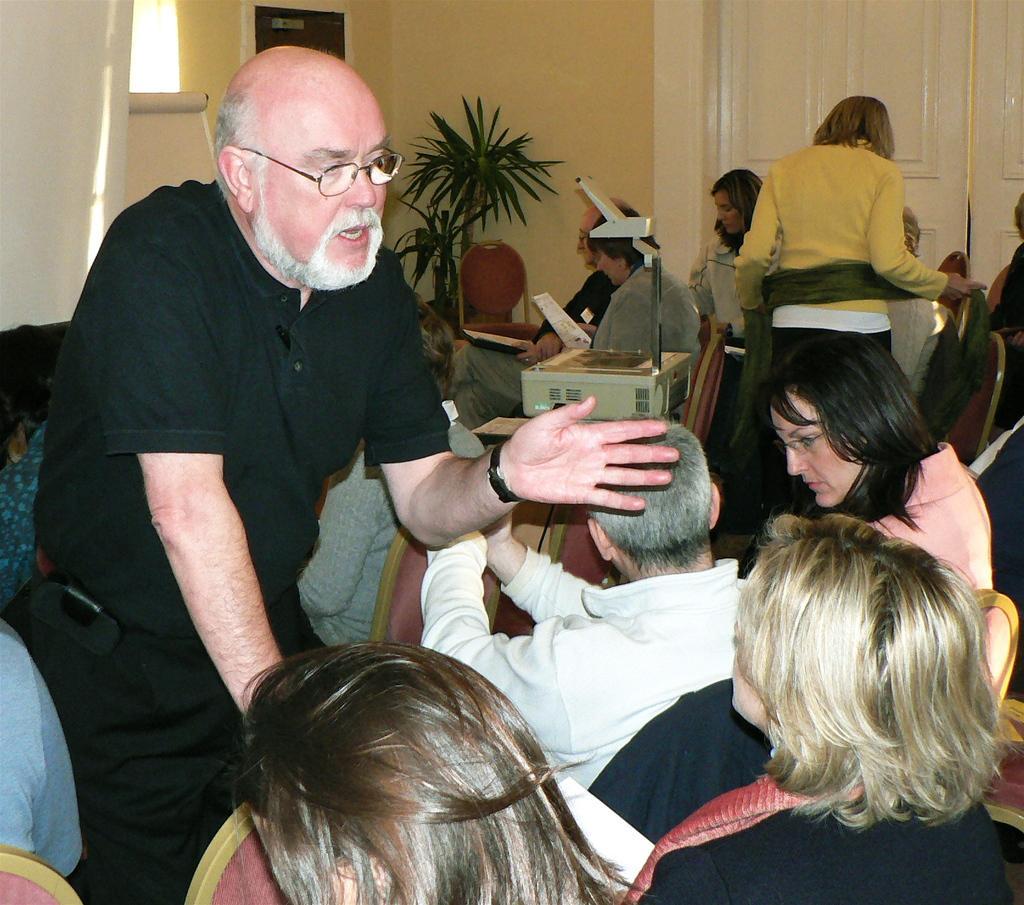How would you summarize this image in a sentence or two? In this image, we can see some people sitting on the chair, we can see a man standing, we can see a plant and a wall, we can see the doors. 